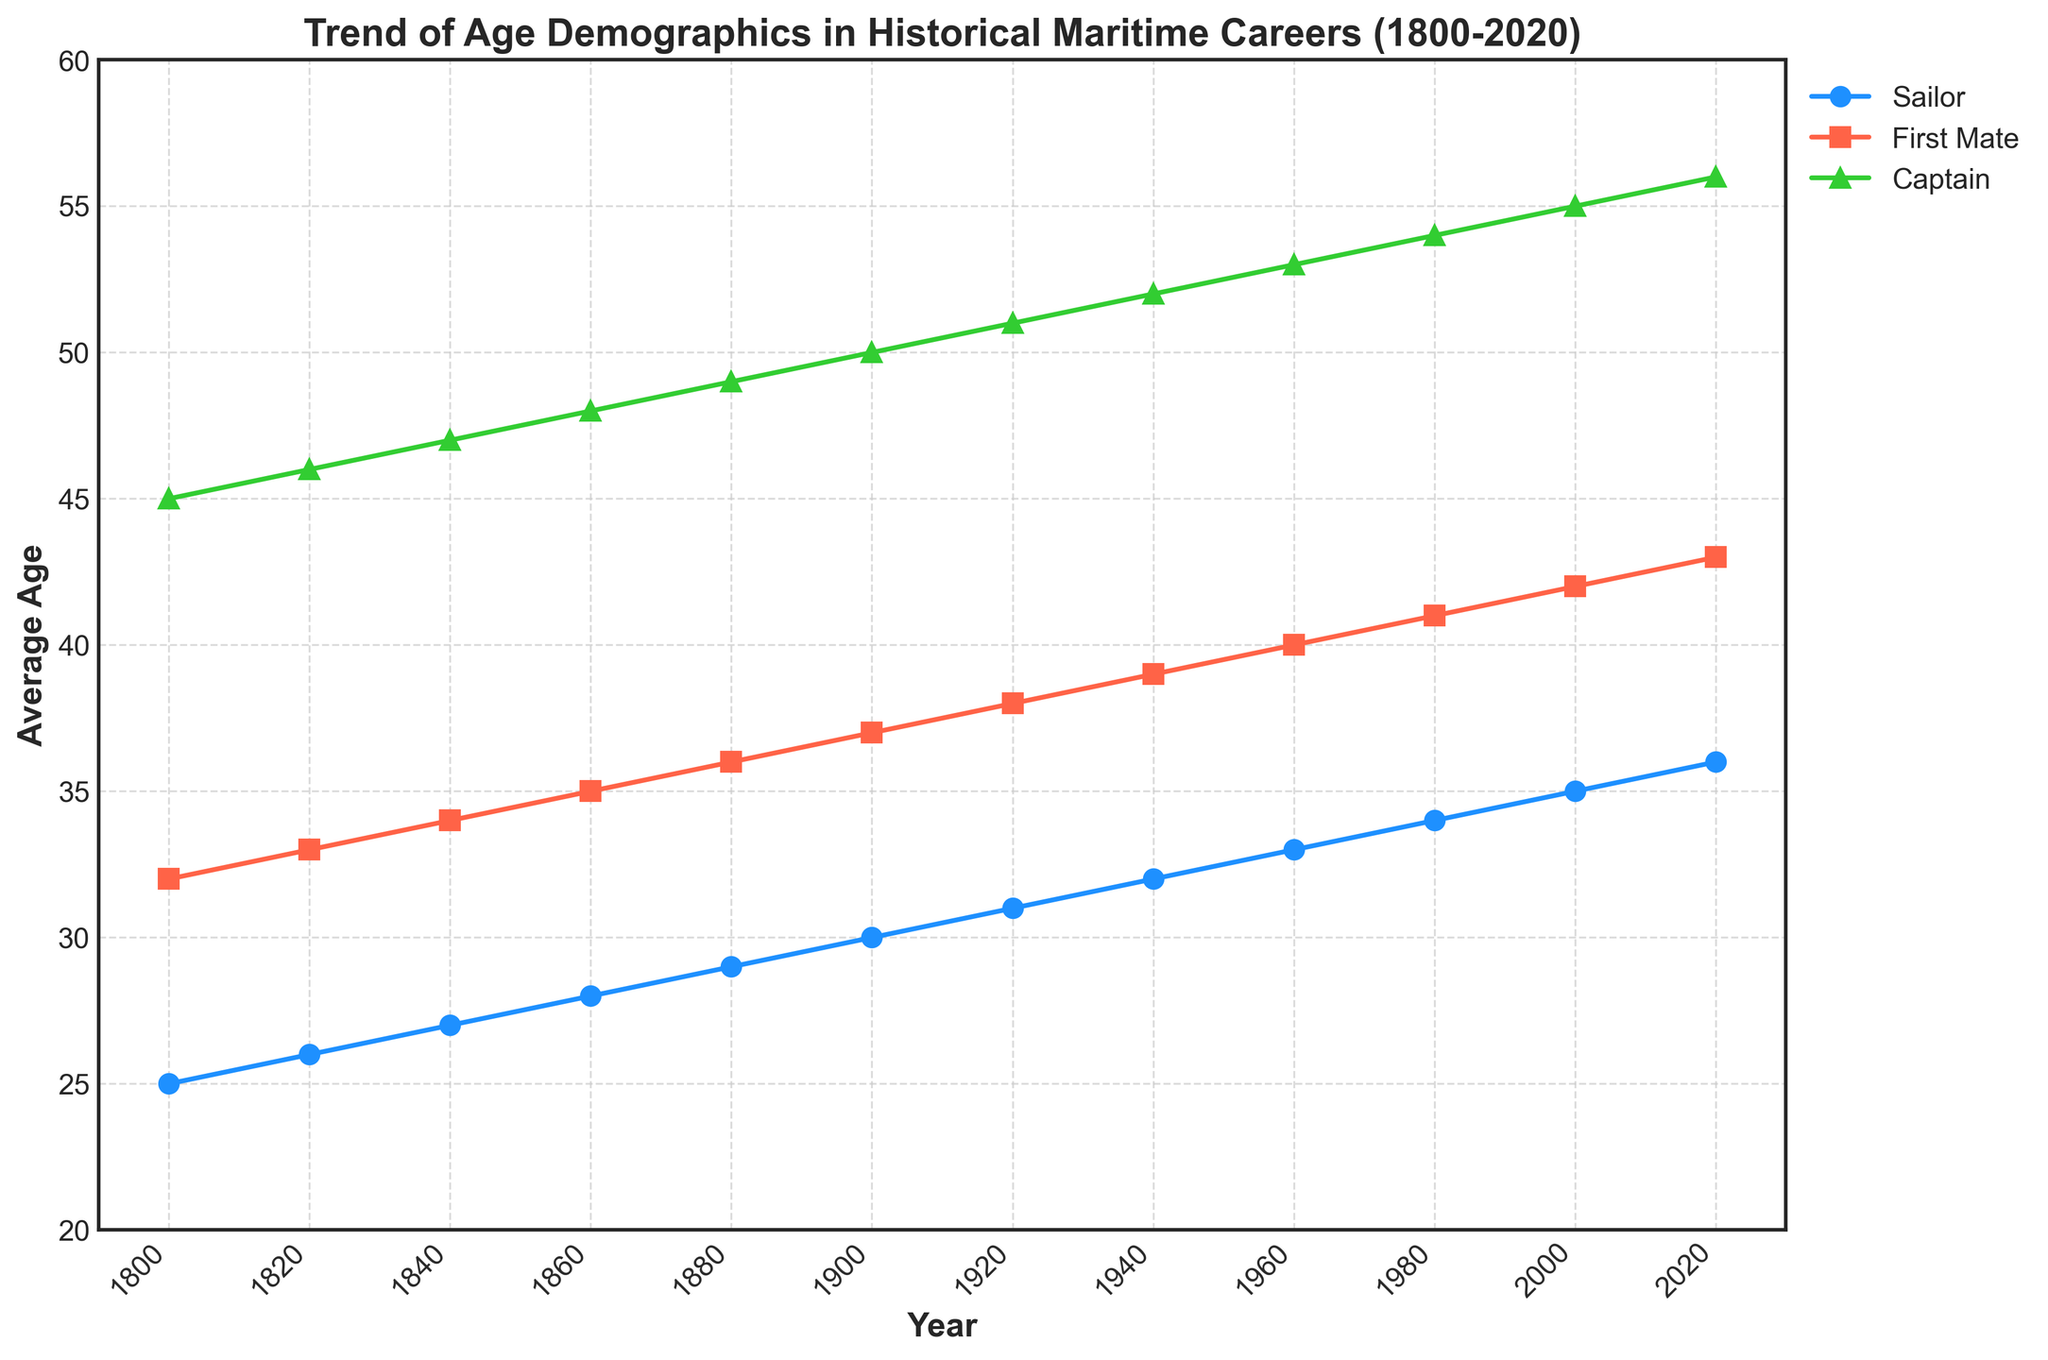What's the title of the plot? The title of the plot is shown at the top of the figure and provides an overview of the information being visualized. It states: 'Trend of Age Demographics in Historical Maritime Careers (1800-2020)'
Answer: Trend of Age Demographics in Historical Maritime Careers (1800-2020) Which role has the highest average age consistently over the years? By observing the time series lines, we can notice that the line representing Captains' average age is consistently higher than the other roles from 1800 to 2020.
Answer: Captain In what year does the average age of Sailors reach 30? Looking at the plot and tracing the line for Sailors, we can see that the average age of Sailors reaches 30 around the year 1900.
Answer: 1900 What is the approximate increase in the average age of First Mates from 1800 to 2020? The average age of First Mates in 1800 is 32, and in 2020 it is 43. The increase is calculated as 43 - 32 = 11 years.
Answer: 11 years Do the average ages of all three roles show a rising trend over the years? By examining the general direction of the lines for Sailors, First Mates, and Captains, all lines trend upwards, indicating an increase in average age over time.
Answer: Yes What is the average age of Captains in the year 1940? Finding the data point for Captains in the year 1940 on the plot reveals that the average age is 52.
Answer: 52 Between 1860 and 1880, which role shows the smallest change in average age? By comparing the change in the slopes of the lines between these years for each role, First Mates show the smallest change, going from 35 to 36, which is a change of 1 year.
Answer: First Mate What is the difference in the average age between Sailors and Captains in the year 2020? The average age for Sailors in 2020 is 36, and for Captains, it is 56. The difference is calculated as 56 - 36 = 20 years.
Answer: 20 years Which role shows the smallest rate of increase in average age over the entire period? Comparing the steepness of the slopes of the lines, the Sailors' line is the least steep, indicating the smallest rate of increase in average age over time.
Answer: Sailor 